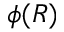<formula> <loc_0><loc_0><loc_500><loc_500>\phi ( R )</formula> 